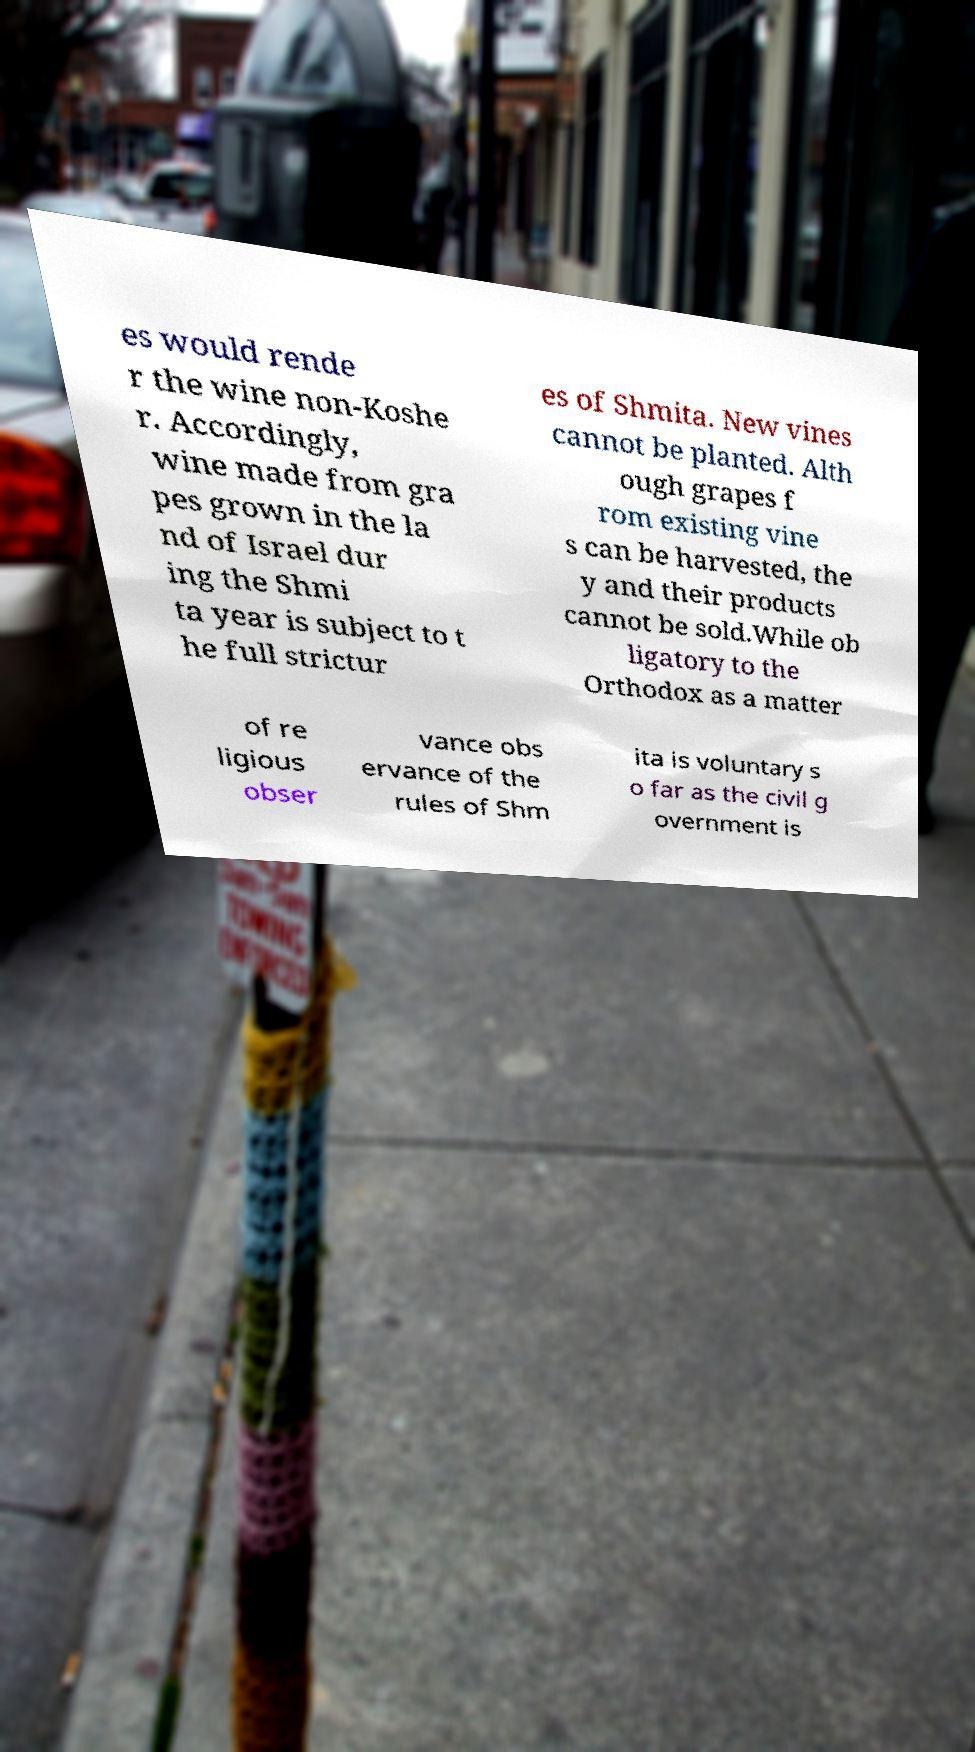Please read and relay the text visible in this image. What does it say? es would rende r the wine non-Koshe r. Accordingly, wine made from gra pes grown in the la nd of Israel dur ing the Shmi ta year is subject to t he full strictur es of Shmita. New vines cannot be planted. Alth ough grapes f rom existing vine s can be harvested, the y and their products cannot be sold.While ob ligatory to the Orthodox as a matter of re ligious obser vance obs ervance of the rules of Shm ita is voluntary s o far as the civil g overnment is 